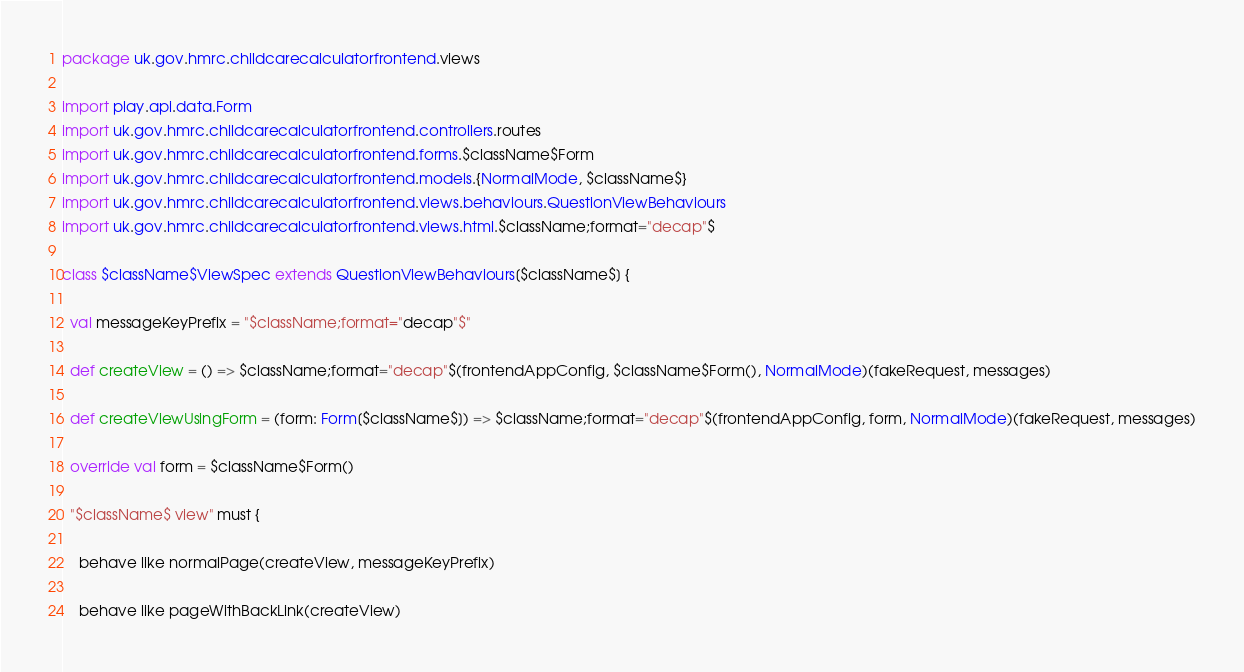<code> <loc_0><loc_0><loc_500><loc_500><_Scala_>package uk.gov.hmrc.childcarecalculatorfrontend.views

import play.api.data.Form
import uk.gov.hmrc.childcarecalculatorfrontend.controllers.routes
import uk.gov.hmrc.childcarecalculatorfrontend.forms.$className$Form
import uk.gov.hmrc.childcarecalculatorfrontend.models.{NormalMode, $className$}
import uk.gov.hmrc.childcarecalculatorfrontend.views.behaviours.QuestionViewBehaviours
import uk.gov.hmrc.childcarecalculatorfrontend.views.html.$className;format="decap"$

class $className$ViewSpec extends QuestionViewBehaviours[$className$] {

  val messageKeyPrefix = "$className;format="decap"$"

  def createView = () => $className;format="decap"$(frontendAppConfig, $className$Form(), NormalMode)(fakeRequest, messages)

  def createViewUsingForm = (form: Form[$className$]) => $className;format="decap"$(frontendAppConfig, form, NormalMode)(fakeRequest, messages)

  override val form = $className$Form()

  "$className$ view" must {

    behave like normalPage(createView, messageKeyPrefix)

    behave like pageWithBackLink(createView)
</code> 